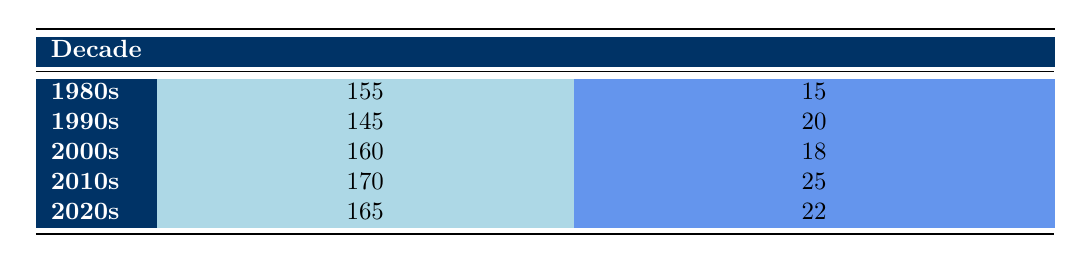What was the average game duration during the 1990s? According to the table, the average game duration for the 1990s is explicitly stated as 145 minutes.
Answer: 145 minutes Which decade had the highest average umpire experience? By looking at the table, the 2010s has the highest average umpire experience noted at 25 years.
Answer: 2010s What was the average game duration difference between the 1980s and 2010s? The average game duration in the 1980s is 155 minutes, while in the 2010s it is 170 minutes. The difference can be calculated as 170 - 155 = 15 minutes.
Answer: 15 minutes Is it true that the average game duration decreased from the 1990s to the 2000s? From the table, the average game duration in the 1990s is 145 minutes, and in the 2000s, it is 160 minutes. Since 160 is greater than 145, the statement is false.
Answer: No What is the average duration of games from the 2020s compared to the 1990s? The average game duration in the 2020s is 165 minutes, while in the 1990s it is 145 minutes. To compare, we see 165 is greater than 145, thus, games in the 2020s take longer on average.
Answer: Longer Which decade had a higher average game duration, the 2000s or the 2020s? In the table, the average game duration for the 2000s is 160 minutes, and for the 2020s, it is 165 minutes. Since 165 is greater than 160, the 2020s had a higher average duration.
Answer: 2020s Calculate the average umpire experience across all decades. To find the average umpire experience, sum the experience years: 15 + 20 + 18 + 25 + 22 = 100. Dividing by the number of decades (5), the average is 100 / 5 = 20 years.
Answer: 20 years Is the average game duration consistently increasing with each decade? By examining the averages listed, we see fluctuations: 155 (1980s) → 145 (1990s) → 160 (2000s) → 170 (2010s) → 165 (2020s). Since it decreases from 1980s to 1990s, the trend is not consistent.
Answer: No 